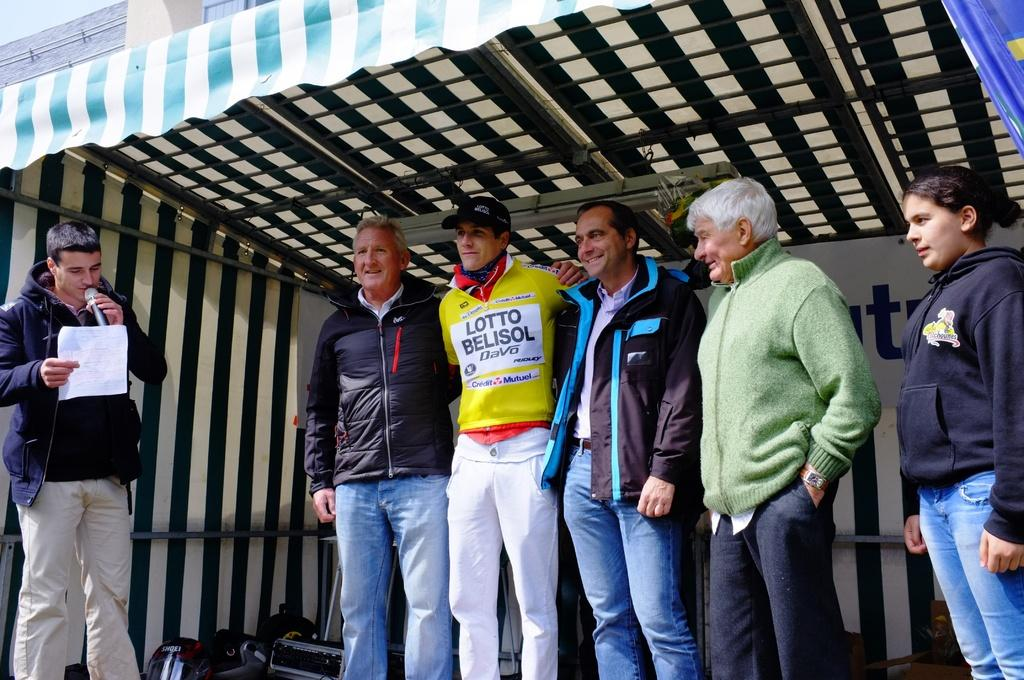<image>
Create a compact narrative representing the image presented. A man reads from a sheet into a microphone while a group of people look on in including a man wearing a sports top with Lotto Belisol on it. 